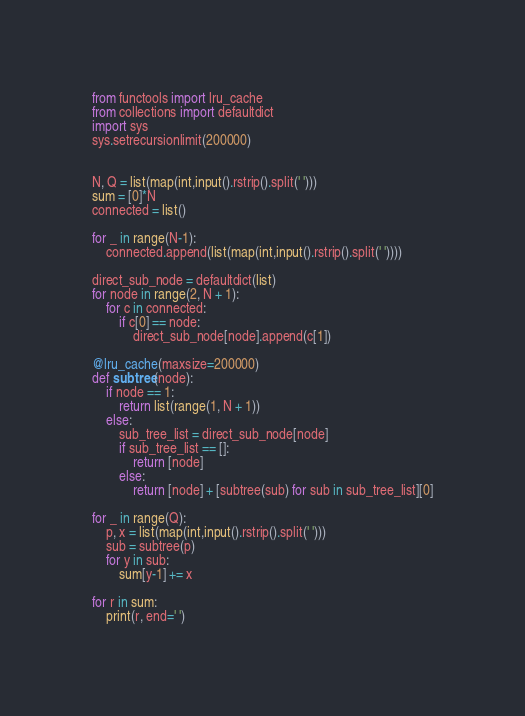<code> <loc_0><loc_0><loc_500><loc_500><_Python_>from functools import lru_cache
from collections import defaultdict
import sys
sys.setrecursionlimit(200000)


N, Q = list(map(int,input().rstrip().split(' ')))
sum = [0]*N
connected = list()

for _ in range(N-1):
    connected.append(list(map(int,input().rstrip().split(' '))))

direct_sub_node = defaultdict(list)
for node in range(2, N + 1):
    for c in connected:
        if c[0] == node:
            direct_sub_node[node].append(c[1])

@lru_cache(maxsize=200000)
def subtree(node):
    if node == 1:
        return list(range(1, N + 1))
    else:
        sub_tree_list = direct_sub_node[node]
        if sub_tree_list == []:
            return [node]
        else:
            return [node] + [subtree(sub) for sub in sub_tree_list][0]

for _ in range(Q):
    p, x = list(map(int,input().rstrip().split(' ')))
    sub = subtree(p)
    for y in sub:
        sum[y-1] += x

for r in sum:
    print(r, end=' ')</code> 